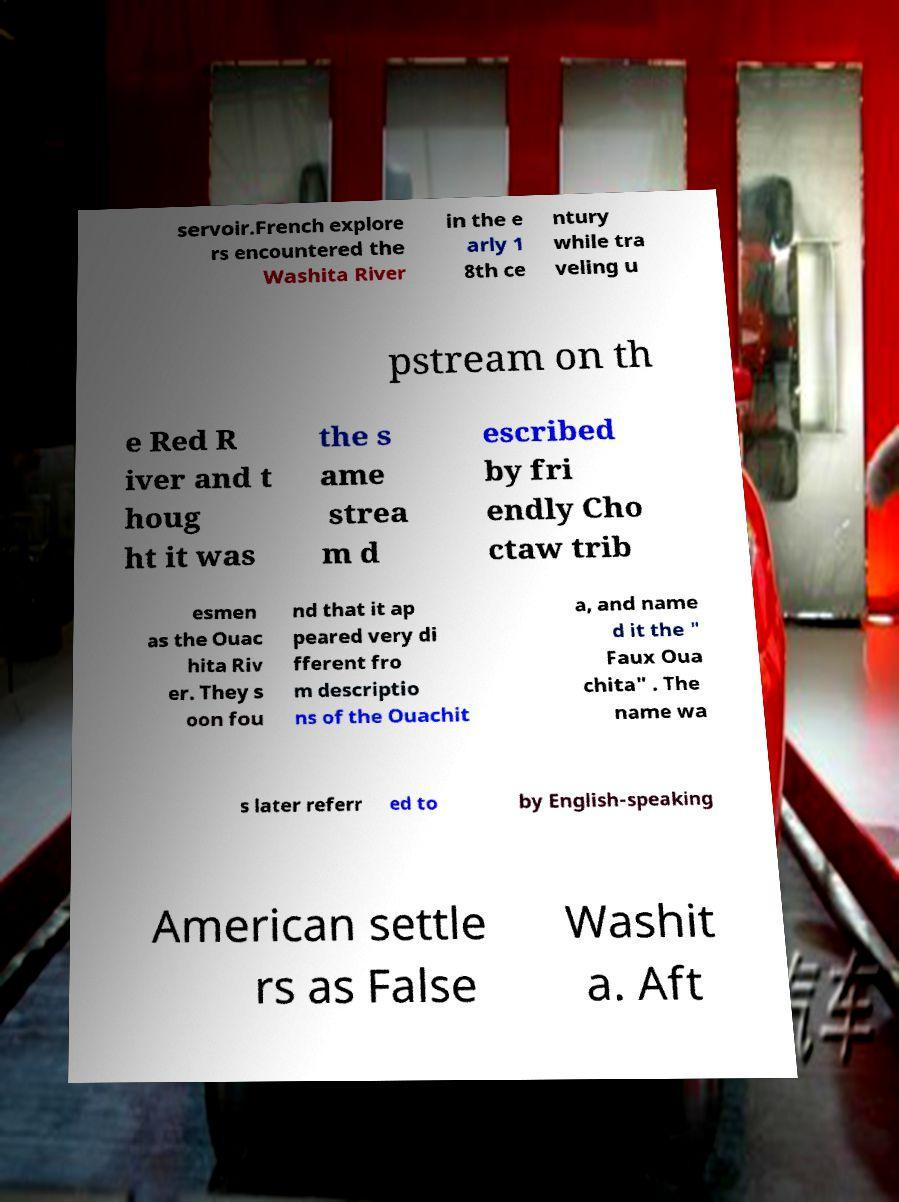For documentation purposes, I need the text within this image transcribed. Could you provide that? servoir.French explore rs encountered the Washita River in the e arly 1 8th ce ntury while tra veling u pstream on th e Red R iver and t houg ht it was the s ame strea m d escribed by fri endly Cho ctaw trib esmen as the Ouac hita Riv er. They s oon fou nd that it ap peared very di fferent fro m descriptio ns of the Ouachit a, and name d it the " Faux Oua chita" . The name wa s later referr ed to by English-speaking American settle rs as False Washit a. Aft 